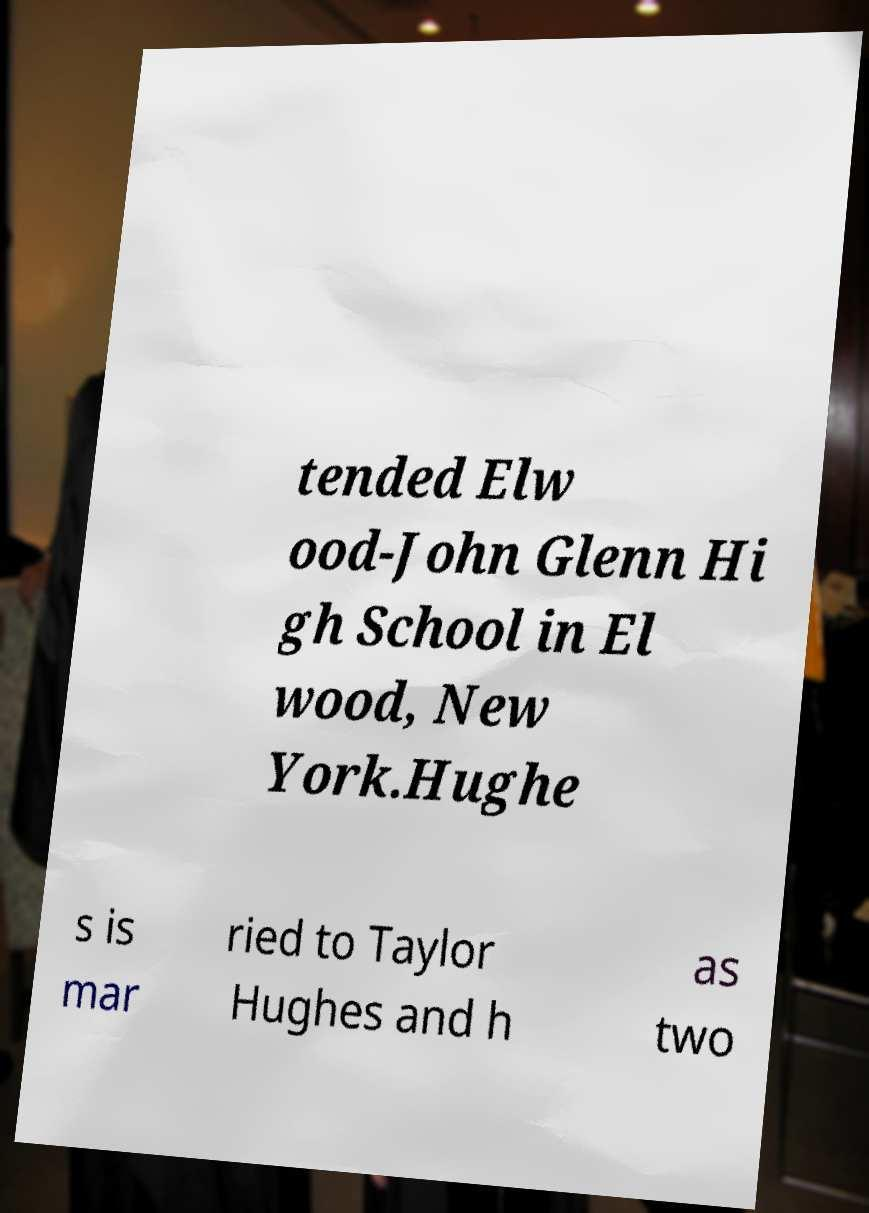Please identify and transcribe the text found in this image. tended Elw ood-John Glenn Hi gh School in El wood, New York.Hughe s is mar ried to Taylor Hughes and h as two 